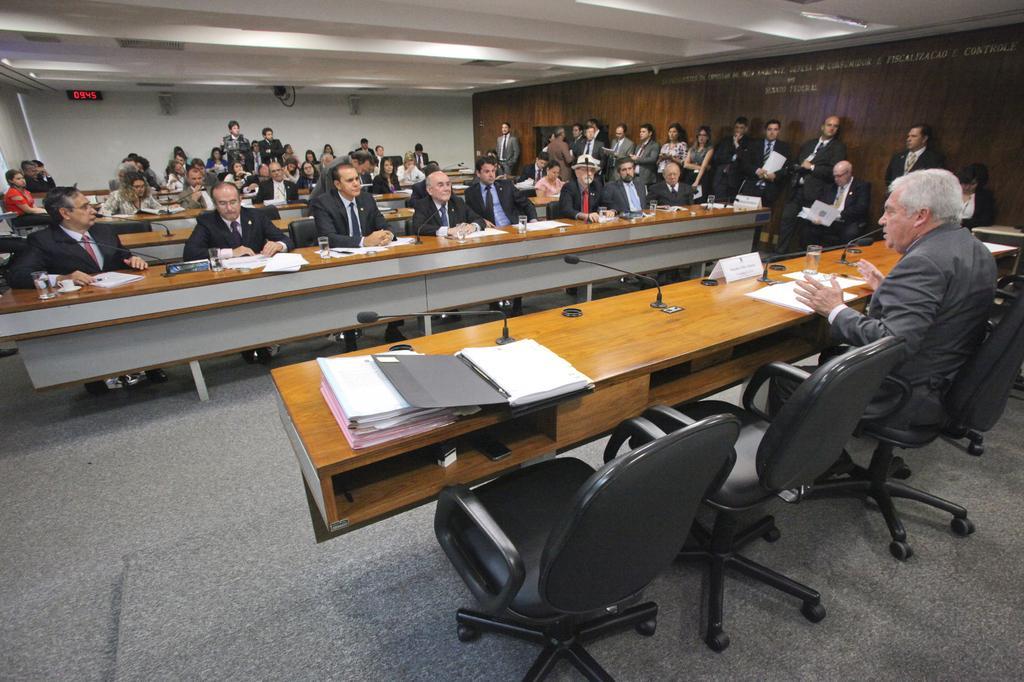Describe this image in one or two sentences. In this picture we can see some persons sitting on the chairs. This is the table. On the table there are some files, and glasses. Here we can see some persons standing on the floor. This is the wall and these are the lights. 